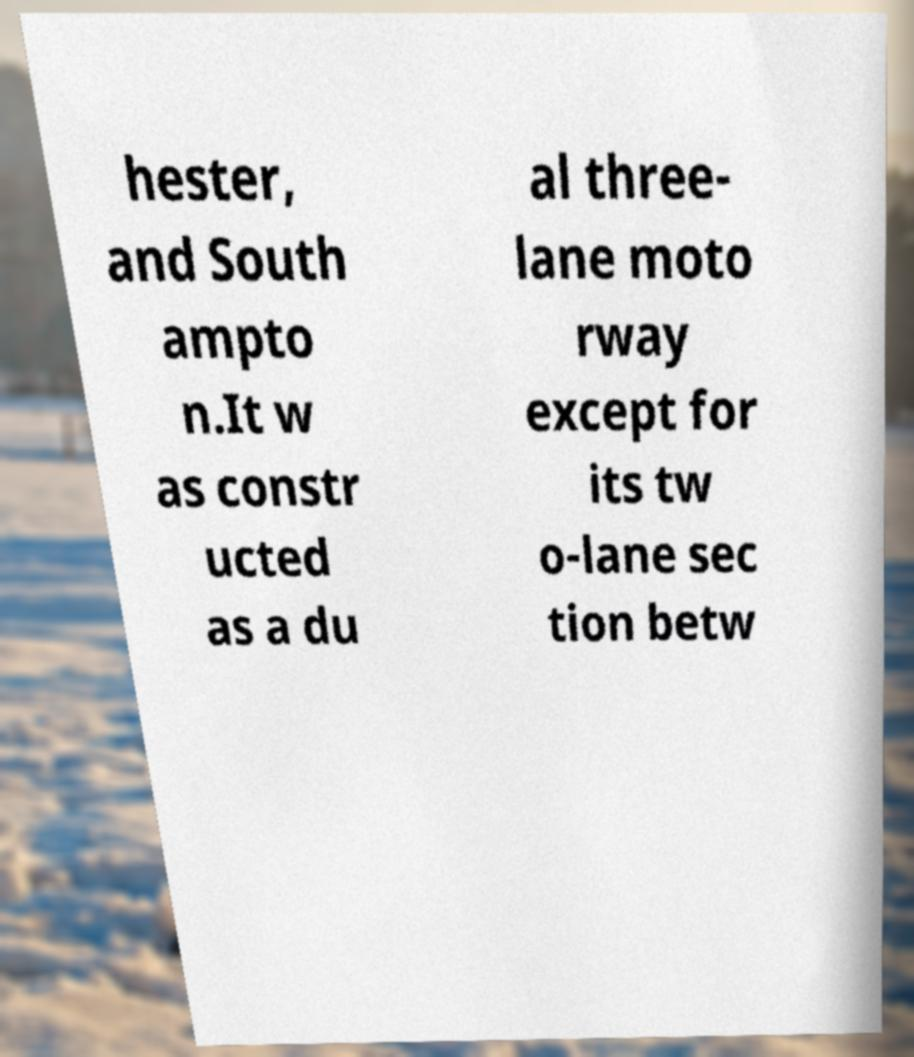Could you extract and type out the text from this image? hester, and South ampto n.It w as constr ucted as a du al three- lane moto rway except for its tw o-lane sec tion betw 